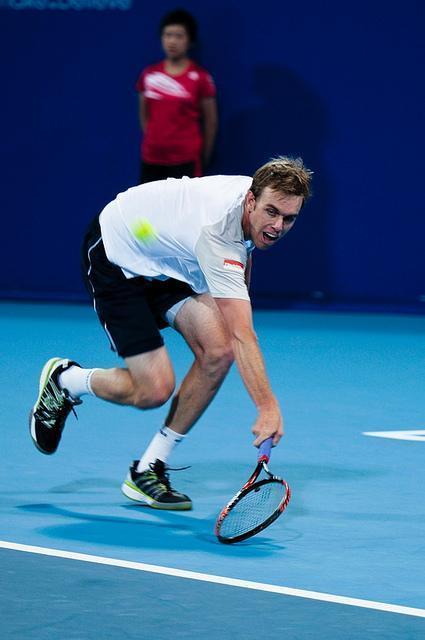How many feet does this person have on the ground?
Give a very brief answer. 1. How many people can you see?
Give a very brief answer. 2. 